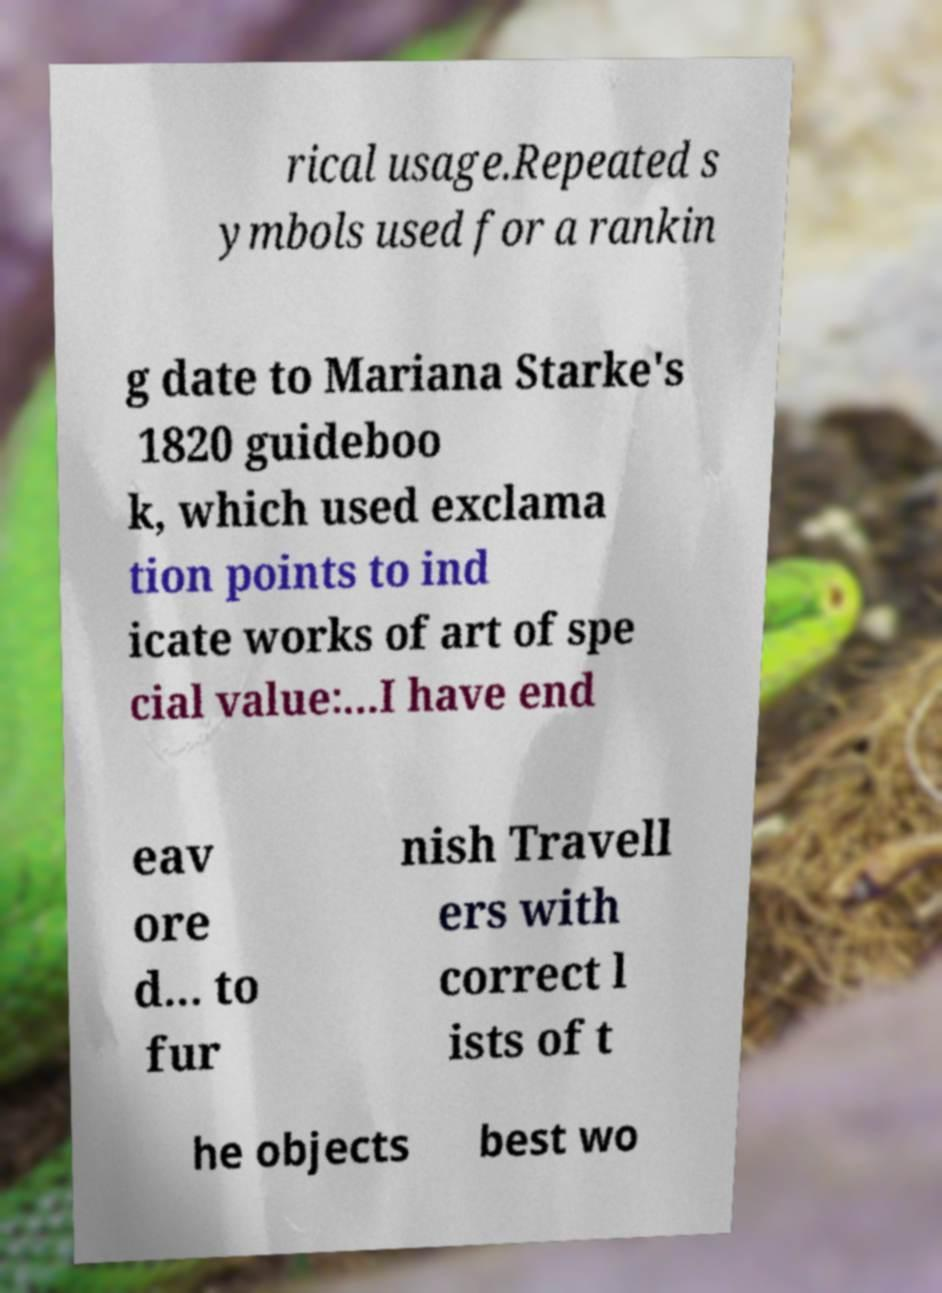What messages or text are displayed in this image? I need them in a readable, typed format. rical usage.Repeated s ymbols used for a rankin g date to Mariana Starke's 1820 guideboo k, which used exclama tion points to ind icate works of art of spe cial value:...I have end eav ore d... to fur nish Travell ers with correct l ists of t he objects best wo 